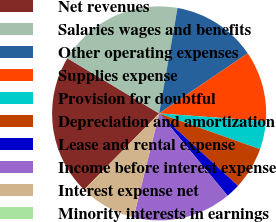Convert chart to OTSL. <chart><loc_0><loc_0><loc_500><loc_500><pie_chart><fcel>Net revenues<fcel>Salaries wages and benefits<fcel>Other operating expenses<fcel>Supplies expense<fcel>Provision for doubtful<fcel>Depreciation and amortization<fcel>Lease and rental expense<fcel>Income before interest expense<fcel>Interest expense net<fcel>Minority interests in earnings<nl><fcel>21.25%<fcel>19.13%<fcel>12.76%<fcel>10.64%<fcel>4.27%<fcel>6.39%<fcel>2.14%<fcel>14.88%<fcel>8.51%<fcel>0.02%<nl></chart> 